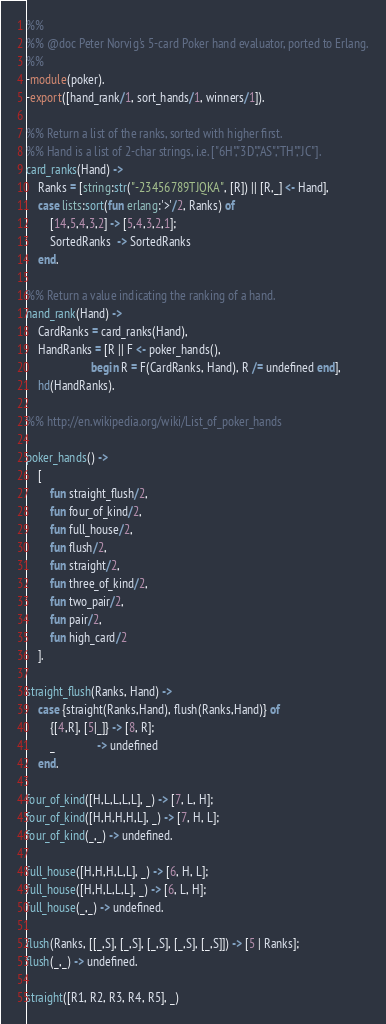<code> <loc_0><loc_0><loc_500><loc_500><_Erlang_>%%
%% @doc Peter Norvig's 5-card Poker hand evaluator, ported to Erlang.
%%
-module(poker).
-export([hand_rank/1, sort_hands/1, winners/1]).

%% Return a list of the ranks, sorted with higher first.
%% Hand is a list of 2-char strings, i.e. ["6H","3D","AS","TH","JC"].
card_ranks(Hand) ->
    Ranks = [string:str("-23456789TJQKA", [R]) || [R,_] <- Hand],
    case lists:sort(fun erlang:'>'/2, Ranks) of
        [14,5,4,3,2] -> [5,4,3,2,1];
        SortedRanks  -> SortedRanks
    end.

%% Return a value indicating the ranking of a hand.
hand_rank(Hand) ->
    CardRanks = card_ranks(Hand),
    HandRanks = [R || F <- poker_hands(),
                      begin R = F(CardRanks, Hand), R /= undefined end],
    hd(HandRanks).

%% http://en.wikipedia.org/wiki/List_of_poker_hands

poker_hands() ->
    [
        fun straight_flush/2,
        fun four_of_kind/2,
        fun full_house/2,
        fun flush/2,
        fun straight/2,
        fun three_of_kind/2,
        fun two_pair/2,
        fun pair/2,
        fun high_card/2
    ].

straight_flush(Ranks, Hand) ->
    case {straight(Ranks,Hand), flush(Ranks,Hand)} of
        {[4,R], [5|_]} -> [8, R];
        _              -> undefined
    end.

four_of_kind([H,L,L,L,L], _) -> [7, L, H];
four_of_kind([H,H,H,H,L], _) -> [7, H, L];
four_of_kind(_,_) -> undefined.

full_house([H,H,H,L,L], _) -> [6, H, L];
full_house([H,H,L,L,L], _) -> [6, L, H];
full_house(_,_) -> undefined.

flush(Ranks, [[_,S], [_,S], [_,S], [_,S], [_,S]]) -> [5 | Ranks];
flush(_,_) -> undefined.

straight([R1, R2, R3, R4, R5], _)</code> 